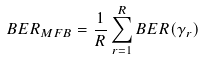<formula> <loc_0><loc_0><loc_500><loc_500>B E R _ { M F B } = \frac { 1 } { R } \sum _ { r = 1 } ^ { R } B E R ( \gamma _ { r } )</formula> 